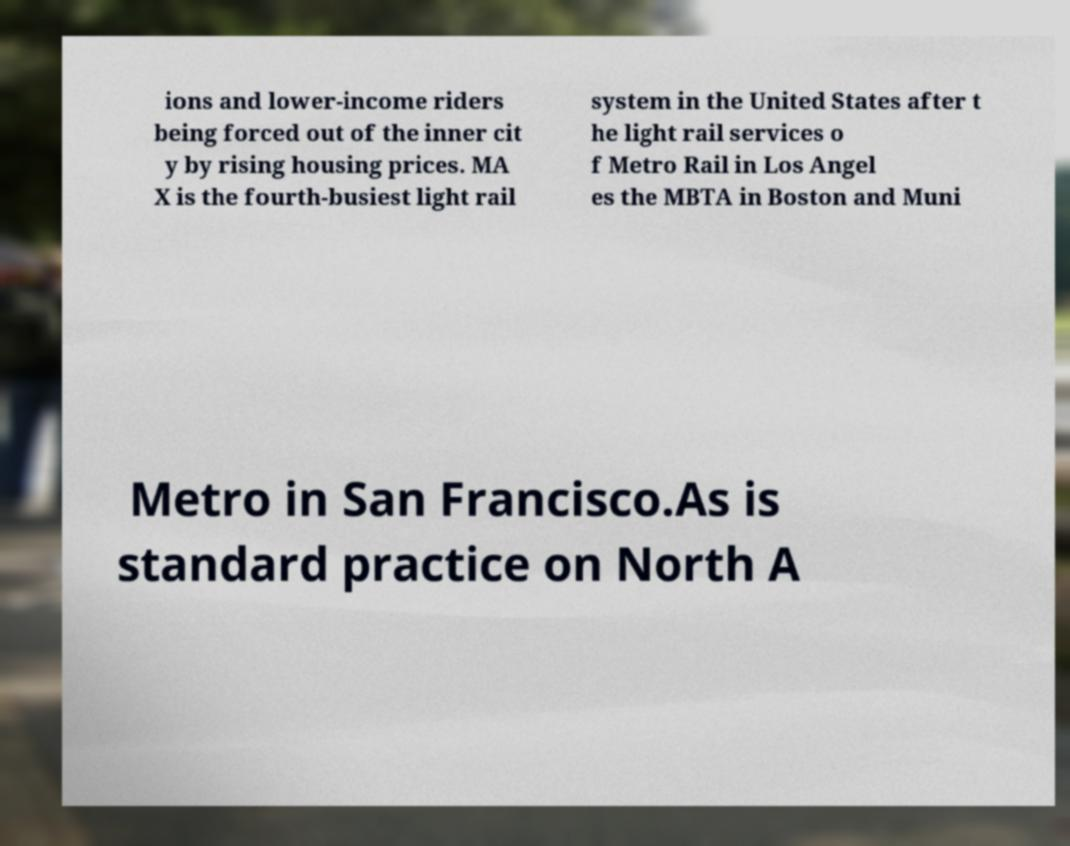Can you read and provide the text displayed in the image?This photo seems to have some interesting text. Can you extract and type it out for me? ions and lower-income riders being forced out of the inner cit y by rising housing prices. MA X is the fourth-busiest light rail system in the United States after t he light rail services o f Metro Rail in Los Angel es the MBTA in Boston and Muni Metro in San Francisco.As is standard practice on North A 